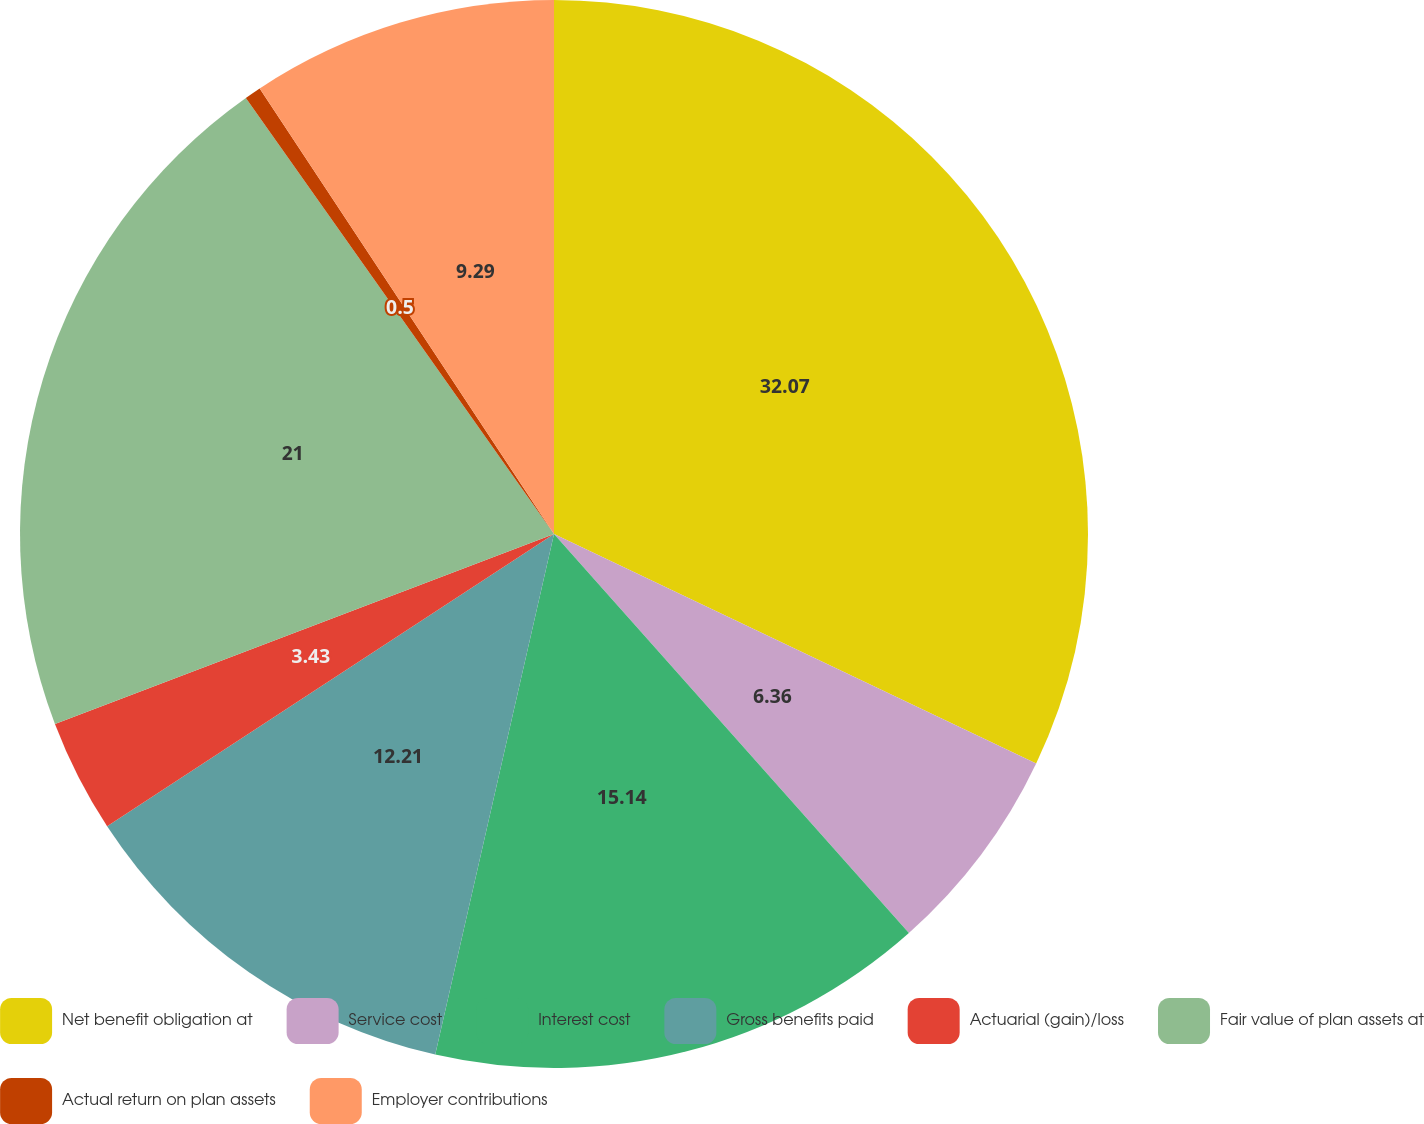<chart> <loc_0><loc_0><loc_500><loc_500><pie_chart><fcel>Net benefit obligation at<fcel>Service cost<fcel>Interest cost<fcel>Gross benefits paid<fcel>Actuarial (gain)/loss<fcel>Fair value of plan assets at<fcel>Actual return on plan assets<fcel>Employer contributions<nl><fcel>32.07%<fcel>6.36%<fcel>15.14%<fcel>12.21%<fcel>3.43%<fcel>21.0%<fcel>0.5%<fcel>9.29%<nl></chart> 